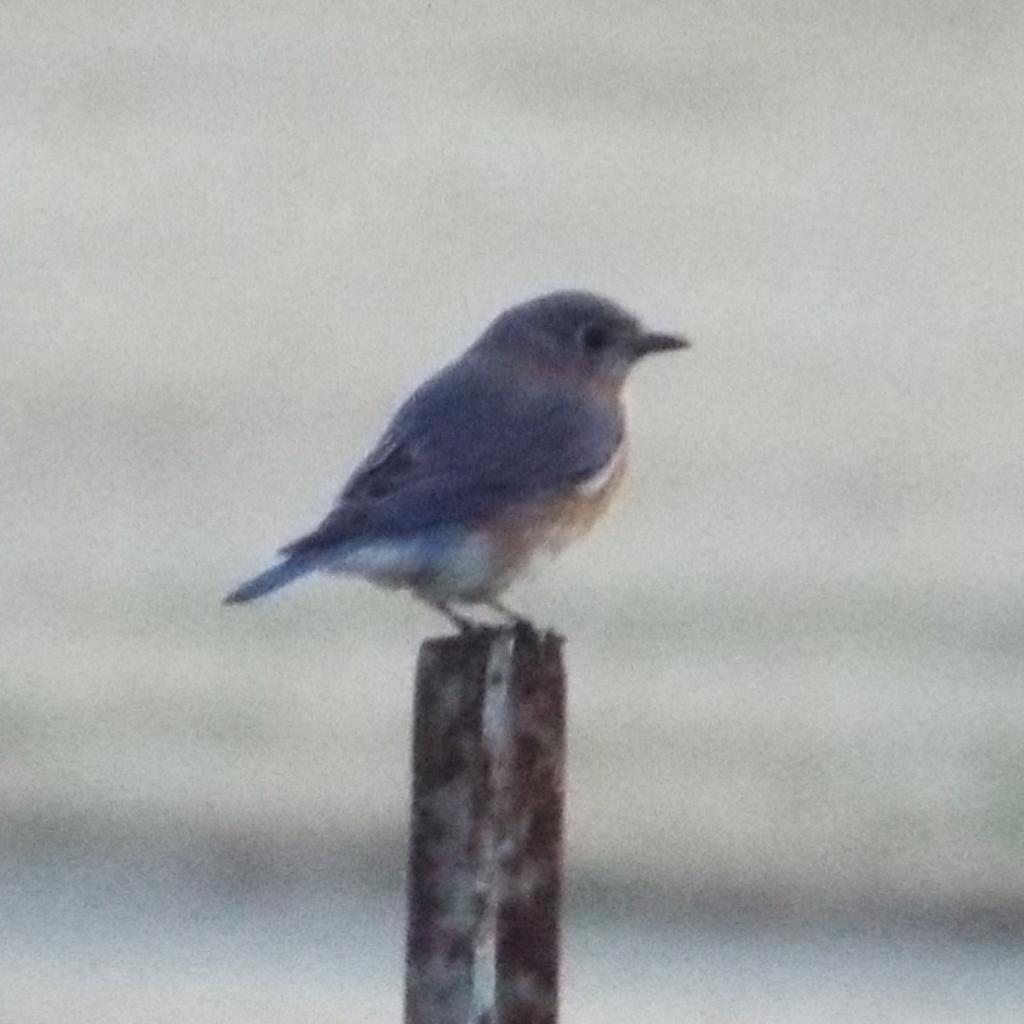What is the main subject of the image? There is a bird in the middle of the image. Can you describe the background of the image? The background of the image is blurry. What type of rice is being served during the meal in the image? There is no meal or rice present in the image; it features a bird with a blurry background. 